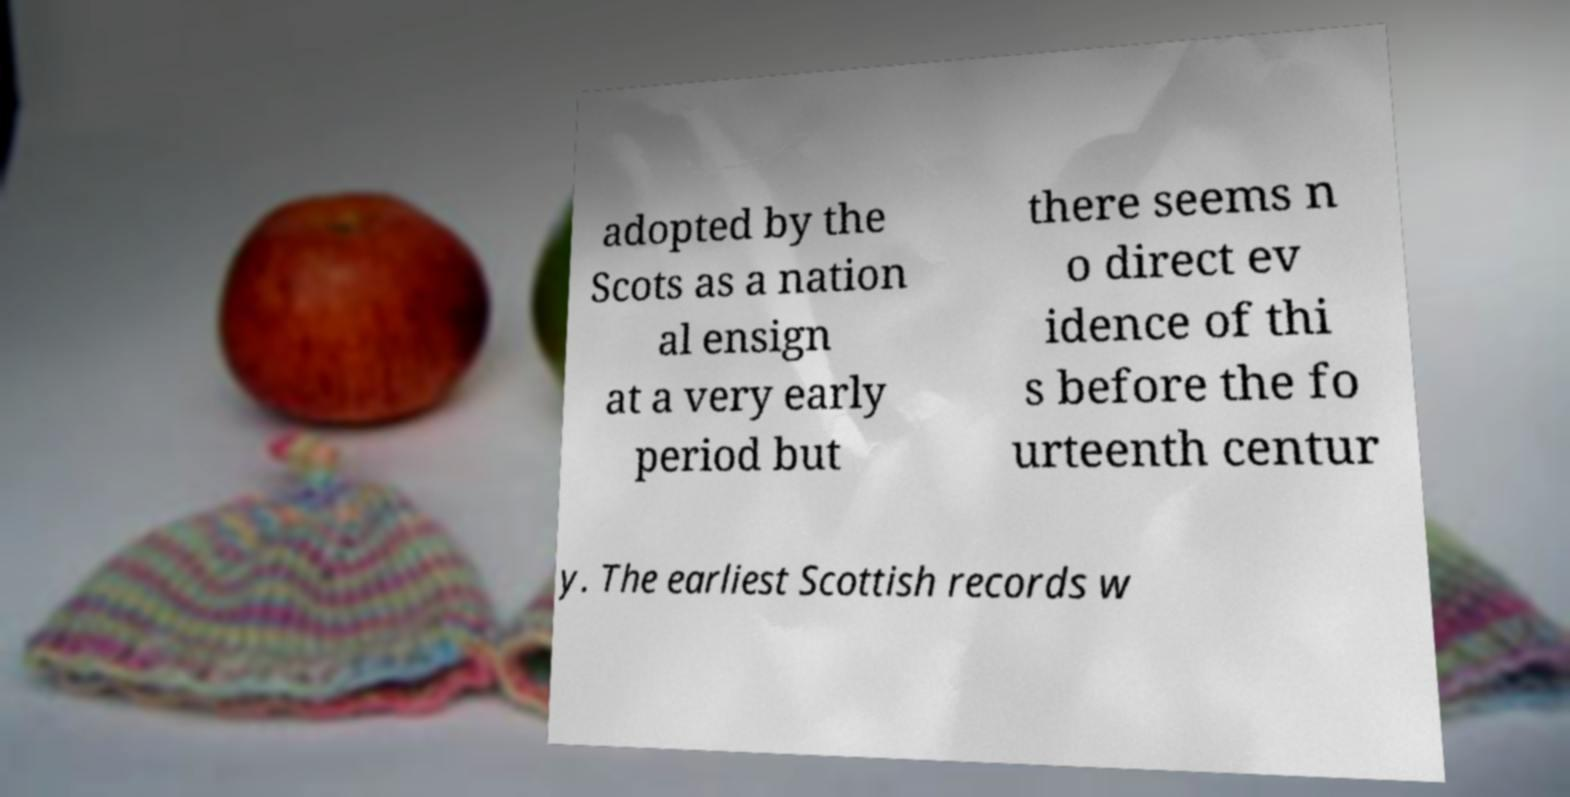Please read and relay the text visible in this image. What does it say? adopted by the Scots as a nation al ensign at a very early period but there seems n o direct ev idence of thi s before the fo urteenth centur y. The earliest Scottish records w 